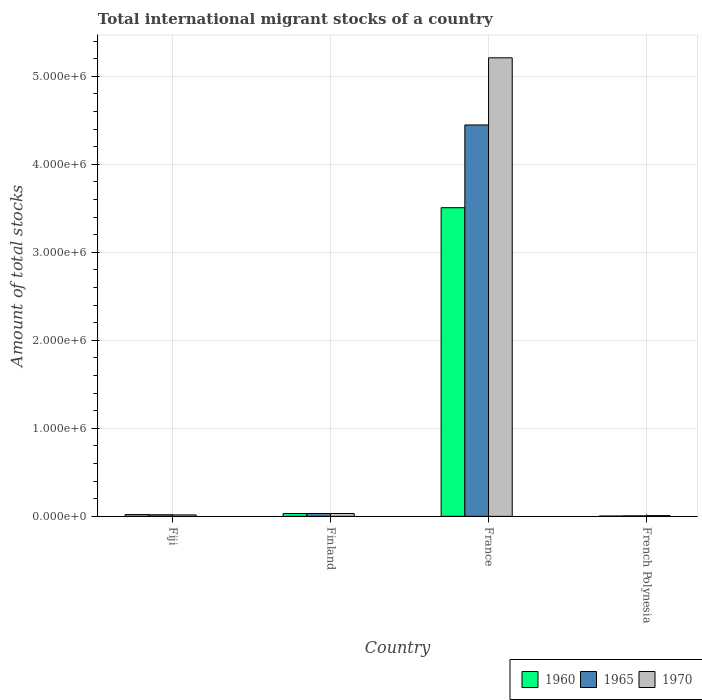How many different coloured bars are there?
Ensure brevity in your answer.  3. Are the number of bars per tick equal to the number of legend labels?
Keep it short and to the point. Yes. Are the number of bars on each tick of the X-axis equal?
Offer a terse response. Yes. What is the label of the 4th group of bars from the left?
Offer a terse response. French Polynesia. In how many cases, is the number of bars for a given country not equal to the number of legend labels?
Make the answer very short. 0. What is the amount of total stocks in in 1965 in France?
Your answer should be very brief. 4.45e+06. Across all countries, what is the maximum amount of total stocks in in 1960?
Ensure brevity in your answer.  3.51e+06. Across all countries, what is the minimum amount of total stocks in in 1960?
Make the answer very short. 3665. In which country was the amount of total stocks in in 1970 maximum?
Provide a short and direct response. France. In which country was the amount of total stocks in in 1965 minimum?
Your response must be concise. French Polynesia. What is the total amount of total stocks in in 1970 in the graph?
Provide a short and direct response. 5.27e+06. What is the difference between the amount of total stocks in in 1965 in Fiji and that in France?
Offer a terse response. -4.43e+06. What is the difference between the amount of total stocks in in 1970 in French Polynesia and the amount of total stocks in in 1960 in Finland?
Your answer should be very brief. -2.39e+04. What is the average amount of total stocks in in 1970 per country?
Your answer should be very brief. 1.32e+06. What is the difference between the amount of total stocks in of/in 1960 and amount of total stocks in of/in 1970 in Finland?
Offer a terse response. -407. In how many countries, is the amount of total stocks in in 1960 greater than 2400000?
Provide a succinct answer. 1. What is the ratio of the amount of total stocks in in 1960 in France to that in French Polynesia?
Give a very brief answer. 956.95. Is the amount of total stocks in in 1965 in Fiji less than that in Finland?
Keep it short and to the point. Yes. What is the difference between the highest and the second highest amount of total stocks in in 1960?
Keep it short and to the point. -3.48e+06. What is the difference between the highest and the lowest amount of total stocks in in 1970?
Your answer should be compact. 5.20e+06. In how many countries, is the amount of total stocks in in 1970 greater than the average amount of total stocks in in 1970 taken over all countries?
Make the answer very short. 1. What does the 2nd bar from the left in French Polynesia represents?
Your response must be concise. 1965. What does the 2nd bar from the right in French Polynesia represents?
Your answer should be compact. 1965. Is it the case that in every country, the sum of the amount of total stocks in in 1970 and amount of total stocks in in 1965 is greater than the amount of total stocks in in 1960?
Provide a short and direct response. Yes. Are all the bars in the graph horizontal?
Your answer should be very brief. No. How many countries are there in the graph?
Your response must be concise. 4. What is the difference between two consecutive major ticks on the Y-axis?
Give a very brief answer. 1.00e+06. Are the values on the major ticks of Y-axis written in scientific E-notation?
Your answer should be very brief. Yes. Where does the legend appear in the graph?
Keep it short and to the point. Bottom right. How many legend labels are there?
Your answer should be very brief. 3. What is the title of the graph?
Provide a short and direct response. Total international migrant stocks of a country. Does "1984" appear as one of the legend labels in the graph?
Make the answer very short. No. What is the label or title of the X-axis?
Your response must be concise. Country. What is the label or title of the Y-axis?
Your answer should be very brief. Amount of total stocks. What is the Amount of total stocks in 1960 in Fiji?
Give a very brief answer. 2.01e+04. What is the Amount of total stocks of 1965 in Fiji?
Your answer should be compact. 1.80e+04. What is the Amount of total stocks in 1970 in Fiji?
Your response must be concise. 1.64e+04. What is the Amount of total stocks in 1960 in Finland?
Ensure brevity in your answer.  3.21e+04. What is the Amount of total stocks of 1965 in Finland?
Make the answer very short. 3.22e+04. What is the Amount of total stocks of 1970 in Finland?
Offer a very short reply. 3.25e+04. What is the Amount of total stocks in 1960 in France?
Your answer should be very brief. 3.51e+06. What is the Amount of total stocks in 1965 in France?
Your answer should be very brief. 4.45e+06. What is the Amount of total stocks of 1970 in France?
Ensure brevity in your answer.  5.21e+06. What is the Amount of total stocks of 1960 in French Polynesia?
Ensure brevity in your answer.  3665. What is the Amount of total stocks of 1965 in French Polynesia?
Keep it short and to the point. 5480. What is the Amount of total stocks of 1970 in French Polynesia?
Your answer should be compact. 8194. Across all countries, what is the maximum Amount of total stocks in 1960?
Your answer should be very brief. 3.51e+06. Across all countries, what is the maximum Amount of total stocks in 1965?
Your answer should be compact. 4.45e+06. Across all countries, what is the maximum Amount of total stocks of 1970?
Your answer should be very brief. 5.21e+06. Across all countries, what is the minimum Amount of total stocks of 1960?
Provide a succinct answer. 3665. Across all countries, what is the minimum Amount of total stocks of 1965?
Offer a very short reply. 5480. Across all countries, what is the minimum Amount of total stocks in 1970?
Ensure brevity in your answer.  8194. What is the total Amount of total stocks in 1960 in the graph?
Your answer should be very brief. 3.56e+06. What is the total Amount of total stocks in 1965 in the graph?
Offer a very short reply. 4.50e+06. What is the total Amount of total stocks in 1970 in the graph?
Ensure brevity in your answer.  5.27e+06. What is the difference between the Amount of total stocks in 1960 in Fiji and that in Finland?
Ensure brevity in your answer.  -1.20e+04. What is the difference between the Amount of total stocks in 1965 in Fiji and that in Finland?
Provide a succinct answer. -1.42e+04. What is the difference between the Amount of total stocks of 1970 in Fiji and that in Finland?
Provide a succinct answer. -1.61e+04. What is the difference between the Amount of total stocks in 1960 in Fiji and that in France?
Keep it short and to the point. -3.49e+06. What is the difference between the Amount of total stocks in 1965 in Fiji and that in France?
Offer a terse response. -4.43e+06. What is the difference between the Amount of total stocks of 1970 in Fiji and that in France?
Keep it short and to the point. -5.19e+06. What is the difference between the Amount of total stocks of 1960 in Fiji and that in French Polynesia?
Offer a very short reply. 1.64e+04. What is the difference between the Amount of total stocks in 1965 in Fiji and that in French Polynesia?
Your answer should be very brief. 1.25e+04. What is the difference between the Amount of total stocks in 1970 in Fiji and that in French Polynesia?
Ensure brevity in your answer.  8200. What is the difference between the Amount of total stocks in 1960 in Finland and that in France?
Make the answer very short. -3.48e+06. What is the difference between the Amount of total stocks in 1965 in Finland and that in France?
Provide a succinct answer. -4.42e+06. What is the difference between the Amount of total stocks in 1970 in Finland and that in France?
Give a very brief answer. -5.18e+06. What is the difference between the Amount of total stocks in 1960 in Finland and that in French Polynesia?
Provide a short and direct response. 2.84e+04. What is the difference between the Amount of total stocks in 1965 in Finland and that in French Polynesia?
Your answer should be very brief. 2.67e+04. What is the difference between the Amount of total stocks of 1970 in Finland and that in French Polynesia?
Give a very brief answer. 2.43e+04. What is the difference between the Amount of total stocks of 1960 in France and that in French Polynesia?
Your response must be concise. 3.50e+06. What is the difference between the Amount of total stocks of 1965 in France and that in French Polynesia?
Offer a terse response. 4.44e+06. What is the difference between the Amount of total stocks in 1970 in France and that in French Polynesia?
Provide a succinct answer. 5.20e+06. What is the difference between the Amount of total stocks in 1960 in Fiji and the Amount of total stocks in 1965 in Finland?
Provide a short and direct response. -1.21e+04. What is the difference between the Amount of total stocks of 1960 in Fiji and the Amount of total stocks of 1970 in Finland?
Offer a terse response. -1.24e+04. What is the difference between the Amount of total stocks in 1965 in Fiji and the Amount of total stocks in 1970 in Finland?
Your answer should be compact. -1.45e+04. What is the difference between the Amount of total stocks of 1960 in Fiji and the Amount of total stocks of 1965 in France?
Give a very brief answer. -4.43e+06. What is the difference between the Amount of total stocks in 1960 in Fiji and the Amount of total stocks in 1970 in France?
Make the answer very short. -5.19e+06. What is the difference between the Amount of total stocks in 1965 in Fiji and the Amount of total stocks in 1970 in France?
Keep it short and to the point. -5.19e+06. What is the difference between the Amount of total stocks in 1960 in Fiji and the Amount of total stocks in 1965 in French Polynesia?
Your answer should be very brief. 1.46e+04. What is the difference between the Amount of total stocks of 1960 in Fiji and the Amount of total stocks of 1970 in French Polynesia?
Offer a terse response. 1.19e+04. What is the difference between the Amount of total stocks in 1965 in Fiji and the Amount of total stocks in 1970 in French Polynesia?
Make the answer very short. 9759. What is the difference between the Amount of total stocks in 1960 in Finland and the Amount of total stocks in 1965 in France?
Your response must be concise. -4.42e+06. What is the difference between the Amount of total stocks of 1960 in Finland and the Amount of total stocks of 1970 in France?
Your answer should be compact. -5.18e+06. What is the difference between the Amount of total stocks in 1965 in Finland and the Amount of total stocks in 1970 in France?
Ensure brevity in your answer.  -5.18e+06. What is the difference between the Amount of total stocks of 1960 in Finland and the Amount of total stocks of 1965 in French Polynesia?
Offer a terse response. 2.66e+04. What is the difference between the Amount of total stocks of 1960 in Finland and the Amount of total stocks of 1970 in French Polynesia?
Provide a short and direct response. 2.39e+04. What is the difference between the Amount of total stocks in 1965 in Finland and the Amount of total stocks in 1970 in French Polynesia?
Offer a terse response. 2.40e+04. What is the difference between the Amount of total stocks in 1960 in France and the Amount of total stocks in 1965 in French Polynesia?
Ensure brevity in your answer.  3.50e+06. What is the difference between the Amount of total stocks of 1960 in France and the Amount of total stocks of 1970 in French Polynesia?
Ensure brevity in your answer.  3.50e+06. What is the difference between the Amount of total stocks of 1965 in France and the Amount of total stocks of 1970 in French Polynesia?
Your response must be concise. 4.44e+06. What is the average Amount of total stocks in 1960 per country?
Make the answer very short. 8.91e+05. What is the average Amount of total stocks of 1965 per country?
Offer a terse response. 1.13e+06. What is the average Amount of total stocks of 1970 per country?
Make the answer very short. 1.32e+06. What is the difference between the Amount of total stocks in 1960 and Amount of total stocks in 1965 in Fiji?
Provide a short and direct response. 2125. What is the difference between the Amount of total stocks in 1960 and Amount of total stocks in 1970 in Fiji?
Offer a very short reply. 3684. What is the difference between the Amount of total stocks in 1965 and Amount of total stocks in 1970 in Fiji?
Offer a terse response. 1559. What is the difference between the Amount of total stocks in 1960 and Amount of total stocks in 1965 in Finland?
Your answer should be compact. -112. What is the difference between the Amount of total stocks in 1960 and Amount of total stocks in 1970 in Finland?
Make the answer very short. -407. What is the difference between the Amount of total stocks of 1965 and Amount of total stocks of 1970 in Finland?
Keep it short and to the point. -295. What is the difference between the Amount of total stocks in 1960 and Amount of total stocks in 1965 in France?
Give a very brief answer. -9.40e+05. What is the difference between the Amount of total stocks in 1960 and Amount of total stocks in 1970 in France?
Keep it short and to the point. -1.70e+06. What is the difference between the Amount of total stocks in 1965 and Amount of total stocks in 1970 in France?
Give a very brief answer. -7.63e+05. What is the difference between the Amount of total stocks in 1960 and Amount of total stocks in 1965 in French Polynesia?
Offer a terse response. -1815. What is the difference between the Amount of total stocks of 1960 and Amount of total stocks of 1970 in French Polynesia?
Keep it short and to the point. -4529. What is the difference between the Amount of total stocks in 1965 and Amount of total stocks in 1970 in French Polynesia?
Provide a succinct answer. -2714. What is the ratio of the Amount of total stocks in 1960 in Fiji to that in Finland?
Provide a succinct answer. 0.63. What is the ratio of the Amount of total stocks of 1965 in Fiji to that in Finland?
Make the answer very short. 0.56. What is the ratio of the Amount of total stocks of 1970 in Fiji to that in Finland?
Offer a terse response. 0.5. What is the ratio of the Amount of total stocks in 1960 in Fiji to that in France?
Keep it short and to the point. 0.01. What is the ratio of the Amount of total stocks of 1965 in Fiji to that in France?
Make the answer very short. 0. What is the ratio of the Amount of total stocks in 1970 in Fiji to that in France?
Ensure brevity in your answer.  0. What is the ratio of the Amount of total stocks in 1960 in Fiji to that in French Polynesia?
Provide a short and direct response. 5.48. What is the ratio of the Amount of total stocks of 1965 in Fiji to that in French Polynesia?
Offer a terse response. 3.28. What is the ratio of the Amount of total stocks in 1970 in Fiji to that in French Polynesia?
Ensure brevity in your answer.  2. What is the ratio of the Amount of total stocks in 1960 in Finland to that in France?
Offer a terse response. 0.01. What is the ratio of the Amount of total stocks of 1965 in Finland to that in France?
Offer a very short reply. 0.01. What is the ratio of the Amount of total stocks in 1970 in Finland to that in France?
Ensure brevity in your answer.  0.01. What is the ratio of the Amount of total stocks in 1960 in Finland to that in French Polynesia?
Keep it short and to the point. 8.75. What is the ratio of the Amount of total stocks of 1965 in Finland to that in French Polynesia?
Your response must be concise. 5.88. What is the ratio of the Amount of total stocks in 1970 in Finland to that in French Polynesia?
Your answer should be very brief. 3.97. What is the ratio of the Amount of total stocks in 1960 in France to that in French Polynesia?
Your answer should be compact. 956.95. What is the ratio of the Amount of total stocks in 1965 in France to that in French Polynesia?
Your answer should be very brief. 811.54. What is the ratio of the Amount of total stocks in 1970 in France to that in French Polynesia?
Provide a short and direct response. 635.87. What is the difference between the highest and the second highest Amount of total stocks of 1960?
Your answer should be very brief. 3.48e+06. What is the difference between the highest and the second highest Amount of total stocks of 1965?
Your response must be concise. 4.42e+06. What is the difference between the highest and the second highest Amount of total stocks of 1970?
Give a very brief answer. 5.18e+06. What is the difference between the highest and the lowest Amount of total stocks in 1960?
Keep it short and to the point. 3.50e+06. What is the difference between the highest and the lowest Amount of total stocks in 1965?
Your answer should be very brief. 4.44e+06. What is the difference between the highest and the lowest Amount of total stocks of 1970?
Ensure brevity in your answer.  5.20e+06. 